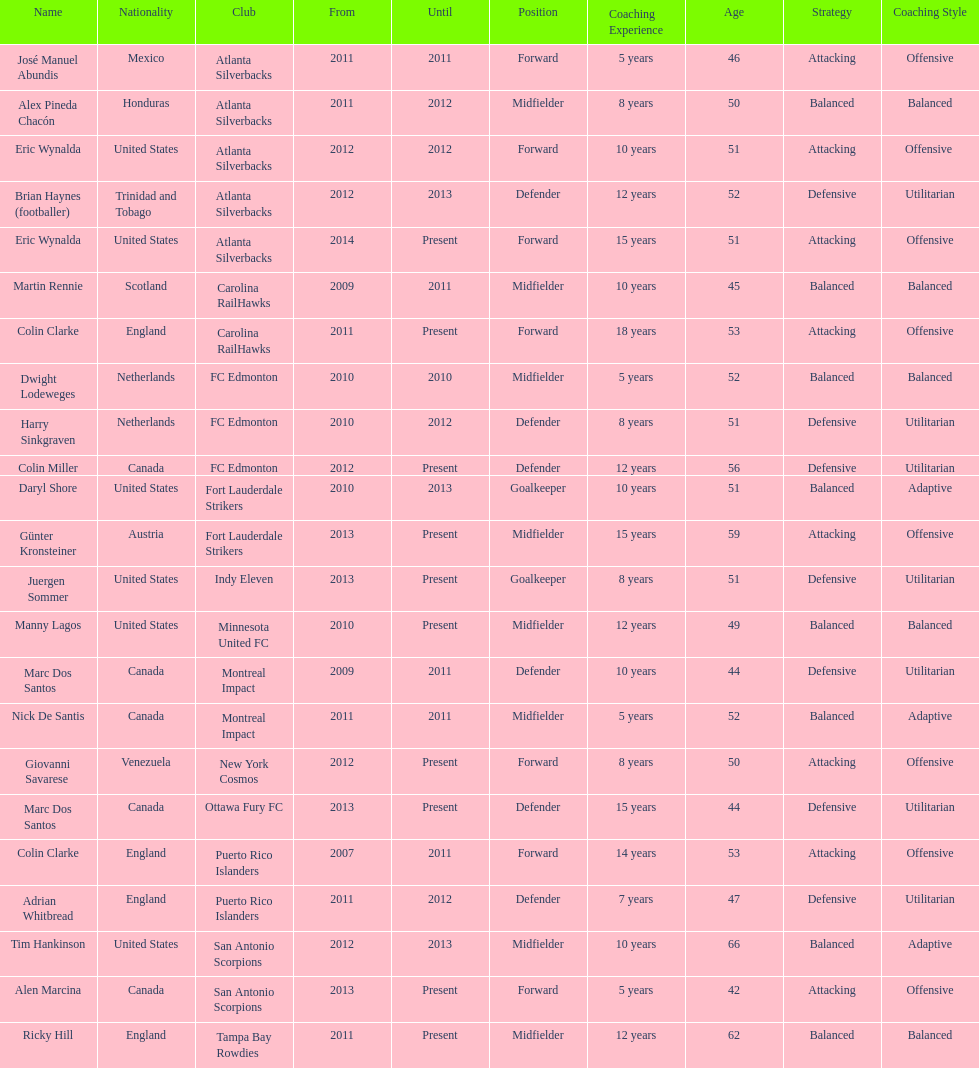Who is the last to coach the san antonio scorpions? Alen Marcina. 